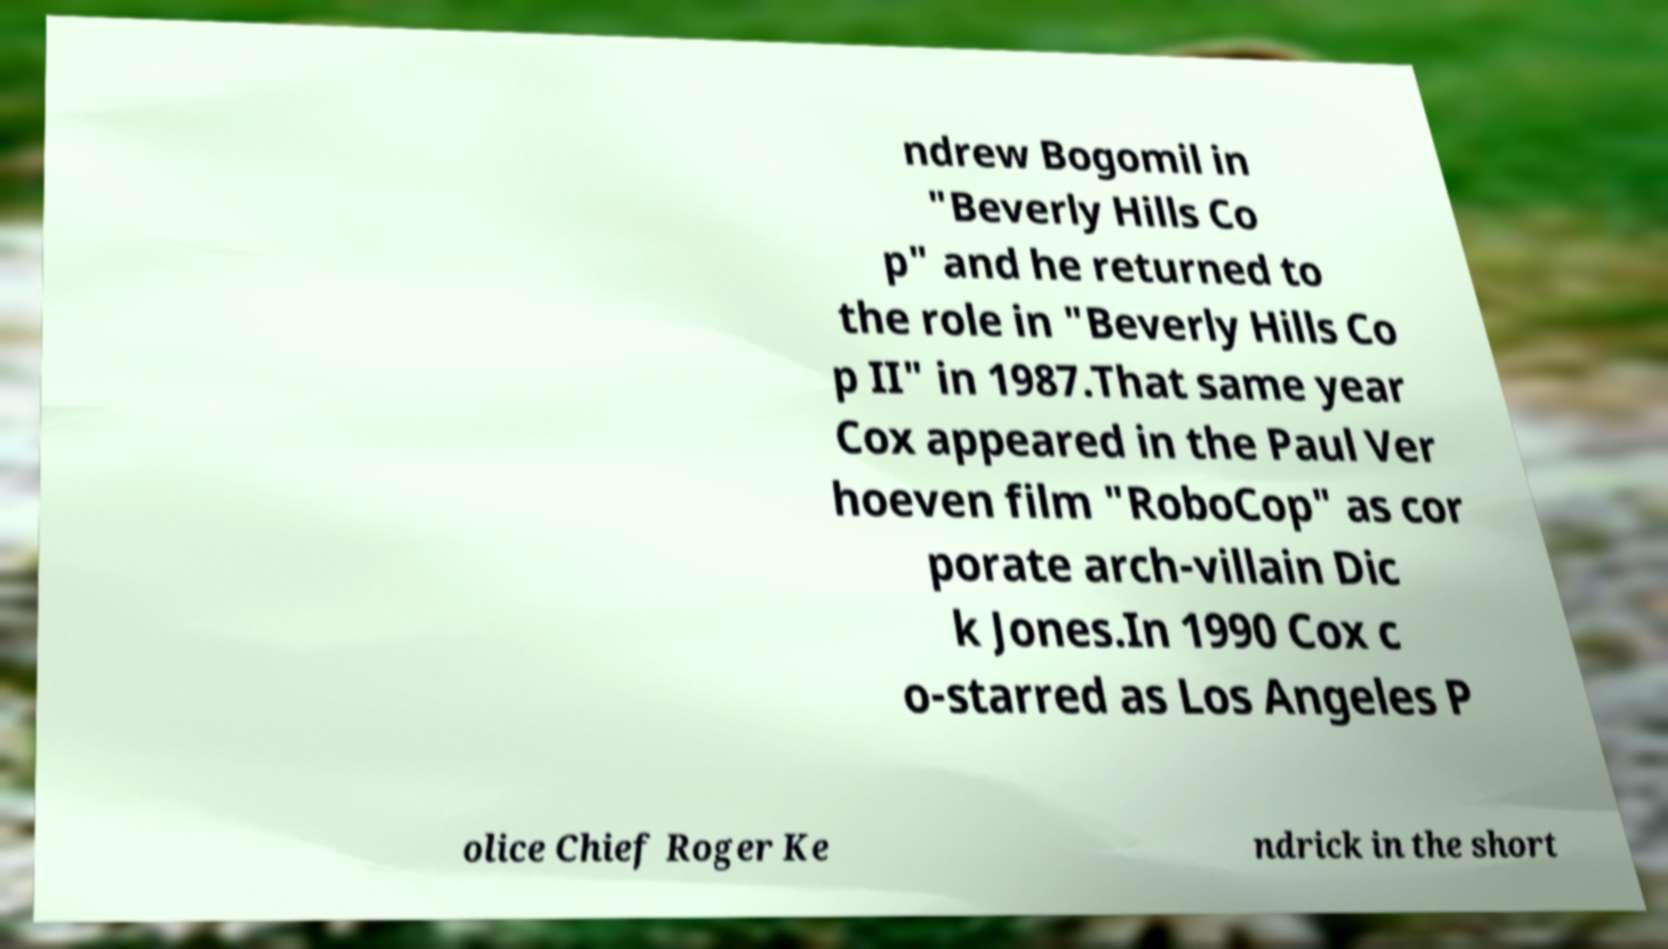Could you assist in decoding the text presented in this image and type it out clearly? ndrew Bogomil in "Beverly Hills Co p" and he returned to the role in "Beverly Hills Co p II" in 1987.That same year Cox appeared in the Paul Ver hoeven film "RoboCop" as cor porate arch-villain Dic k Jones.In 1990 Cox c o-starred as Los Angeles P olice Chief Roger Ke ndrick in the short 